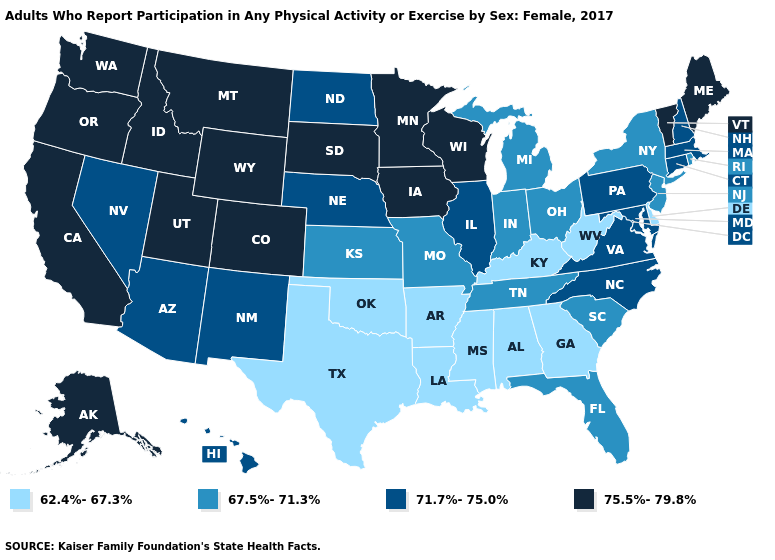Name the states that have a value in the range 62.4%-67.3%?
Write a very short answer. Alabama, Arkansas, Delaware, Georgia, Kentucky, Louisiana, Mississippi, Oklahoma, Texas, West Virginia. Which states have the highest value in the USA?
Concise answer only. Alaska, California, Colorado, Idaho, Iowa, Maine, Minnesota, Montana, Oregon, South Dakota, Utah, Vermont, Washington, Wisconsin, Wyoming. What is the value of Nebraska?
Concise answer only. 71.7%-75.0%. What is the highest value in the MidWest ?
Give a very brief answer. 75.5%-79.8%. Does Texas have the same value as Louisiana?
Be succinct. Yes. Name the states that have a value in the range 71.7%-75.0%?
Short answer required. Arizona, Connecticut, Hawaii, Illinois, Maryland, Massachusetts, Nebraska, Nevada, New Hampshire, New Mexico, North Carolina, North Dakota, Pennsylvania, Virginia. Does Hawaii have the highest value in the West?
Keep it brief. No. Name the states that have a value in the range 67.5%-71.3%?
Write a very short answer. Florida, Indiana, Kansas, Michigan, Missouri, New Jersey, New York, Ohio, Rhode Island, South Carolina, Tennessee. What is the lowest value in the USA?
Be succinct. 62.4%-67.3%. What is the lowest value in the USA?
Be succinct. 62.4%-67.3%. What is the value of Wyoming?
Be succinct. 75.5%-79.8%. What is the highest value in the West ?
Concise answer only. 75.5%-79.8%. Name the states that have a value in the range 67.5%-71.3%?
Quick response, please. Florida, Indiana, Kansas, Michigan, Missouri, New Jersey, New York, Ohio, Rhode Island, South Carolina, Tennessee. Does Idaho have the same value as Alaska?
Be succinct. Yes. Name the states that have a value in the range 62.4%-67.3%?
Give a very brief answer. Alabama, Arkansas, Delaware, Georgia, Kentucky, Louisiana, Mississippi, Oklahoma, Texas, West Virginia. 